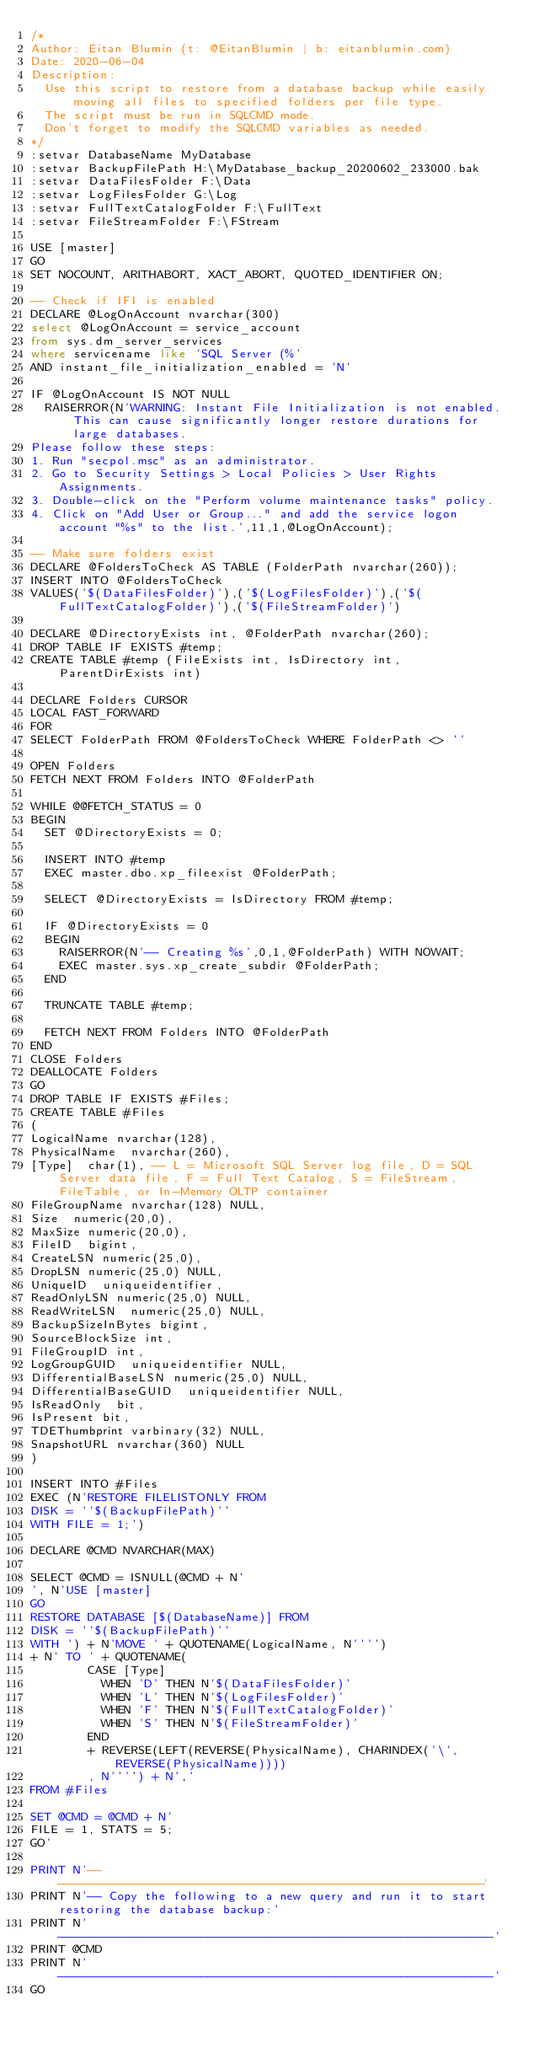Convert code to text. <code><loc_0><loc_0><loc_500><loc_500><_SQL_>/*
Author: Eitan Blumin (t: @EitanBlumin | b: eitanblumin.com)
Date: 2020-06-04
Description:
	Use this script to restore from a database backup while easily moving all files to specified folders per file type.
	The script must be run in SQLCMD mode.
	Don't forget to modify the SQLCMD variables as needed.
*/
:setvar DatabaseName MyDatabase
:setvar BackupFilePath H:\MyDatabase_backup_20200602_233000.bak
:setvar DataFilesFolder F:\Data
:setvar LogFilesFolder G:\Log
:setvar FullTextCatalogFolder F:\FullText
:setvar FileStreamFolder F:\FStream

USE [master]
GO
SET NOCOUNT, ARITHABORT, XACT_ABORT, QUOTED_IDENTIFIER ON;

-- Check if IFI is enabled
DECLARE @LogOnAccount nvarchar(300)
select @LogOnAccount = service_account
from sys.dm_server_services
where servicename like 'SQL Server (%'
AND instant_file_initialization_enabled = 'N'

IF @LogOnAccount IS NOT NULL
	RAISERROR(N'WARNING: Instant File Initialization is not enabled. This can cause significantly longer restore durations for large databases.
Please follow these steps:
1. Run "secpol.msc" as an administrator.
2. Go to Security Settings > Local Policies > User Rights Assignments.
3. Double-click on the "Perform volume maintenance tasks" policy.
4. Click on "Add User or Group..." and add the service logon account "%s" to the list.',11,1,@LogOnAccount);

-- Make sure folders exist
DECLARE @FoldersToCheck AS TABLE (FolderPath nvarchar(260));
INSERT INTO @FoldersToCheck
VALUES('$(DataFilesFolder)'),('$(LogFilesFolder)'),('$(FullTextCatalogFolder)'),('$(FileStreamFolder)')

DECLARE @DirectoryExists int, @FolderPath nvarchar(260);
DROP TABLE IF EXISTS #temp;
CREATE TABLE #temp (FileExists int, IsDirectory int, ParentDirExists int)

DECLARE Folders CURSOR
LOCAL FAST_FORWARD
FOR
SELECT FolderPath FROM @FoldersToCheck WHERE FolderPath <> ''

OPEN Folders
FETCH NEXT FROM Folders INTO @FolderPath

WHILE @@FETCH_STATUS = 0
BEGIN
	SET @DirectoryExists = 0;
	
	INSERT INTO #temp
	EXEC master.dbo.xp_fileexist @FolderPath;

	SELECT @DirectoryExists = IsDirectory FROM #temp;

	IF @DirectoryExists = 0
	BEGIN
		RAISERROR(N'-- Creating %s',0,1,@FolderPath) WITH NOWAIT;
		EXEC master.sys.xp_create_subdir @FolderPath;
	END

	TRUNCATE TABLE #temp;
	
	FETCH NEXT FROM Folders INTO @FolderPath
END
CLOSE Folders
DEALLOCATE Folders
GO
DROP TABLE IF EXISTS #Files;
CREATE TABLE #Files
(
LogicalName	nvarchar(128),
PhysicalName	nvarchar(260),
[Type]	char(1), -- L = Microsoft SQL Server log file, D = SQL Server data file, F = Full Text Catalog, S = FileStream, FileTable, or In-Memory OLTP container
FileGroupName	nvarchar(128) NULL,
Size	numeric(20,0),
MaxSize	numeric(20,0),
FileID	bigint,
CreateLSN	numeric(25,0),
DropLSN	numeric(25,0) NULL,
UniqueID	uniqueidentifier,
ReadOnlyLSN	numeric(25,0) NULL,
ReadWriteLSN	numeric(25,0) NULL,
BackupSizeInBytes	bigint,
SourceBlockSize	int,
FileGroupID	int,
LogGroupGUID	uniqueidentifier NULL,
DifferentialBaseLSN	numeric(25,0) NULL,
DifferentialBaseGUID	uniqueidentifier NULL,
IsReadOnly	bit,
IsPresent	bit,
TDEThumbprint	varbinary(32) NULL,
SnapshotURL	nvarchar(360) NULL
)

INSERT INTO #Files
EXEC (N'RESTORE FILELISTONLY FROM 
DISK = ''$(BackupFilePath)''
WITH FILE = 1;')

DECLARE @CMD NVARCHAR(MAX)

SELECT @CMD = ISNULL(@CMD + N'
', N'USE [master]
GO
RESTORE DATABASE [$(DatabaseName)] FROM 
DISK = ''$(BackupFilePath)''
WITH ') + N'MOVE ' + QUOTENAME(LogicalName, N'''') 
+ N' TO ' + QUOTENAME(
				CASE [Type]
					WHEN 'D' THEN N'$(DataFilesFolder)'
					WHEN 'L' THEN N'$(LogFilesFolder)'
					WHEN 'F' THEN N'$(FullTextCatalogFolder)'
					WHEN 'S' THEN N'$(FileStreamFolder)'
				END
				+ REVERSE(LEFT(REVERSE(PhysicalName), CHARINDEX('\', REVERSE(PhysicalName))))
				, N'''') + N','
FROM #Files

SET @CMD = @CMD + N'
FILE = 1, STATS = 5;
GO'

PRINT N'-------------------------------------------------------------'
PRINT N'-- Copy the following to a new query and run it to start restoring the database backup:'
PRINT N'-------------------------------------------------------------'
PRINT @CMD
PRINT N'-------------------------------------------------------------'
GO</code> 